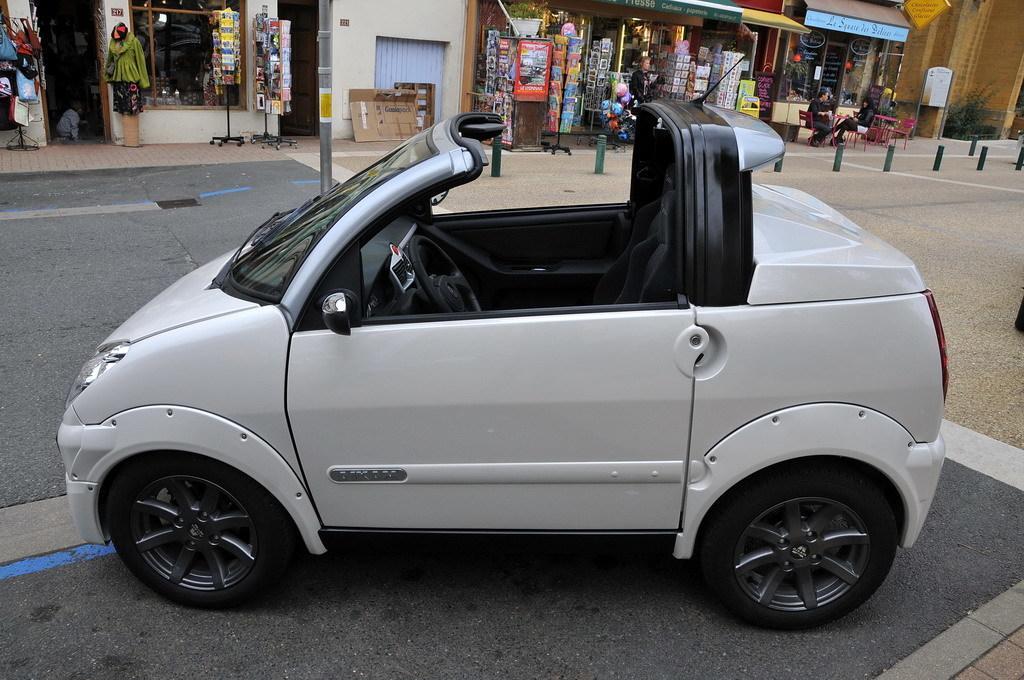Describe this image in one or two sentences. In the foreground I can see a car on the road. In the background I can see a fence, shops, houseplants, wall, boards and a group of people are sitting on the chairs in front of the table. This image is taken during a day. 